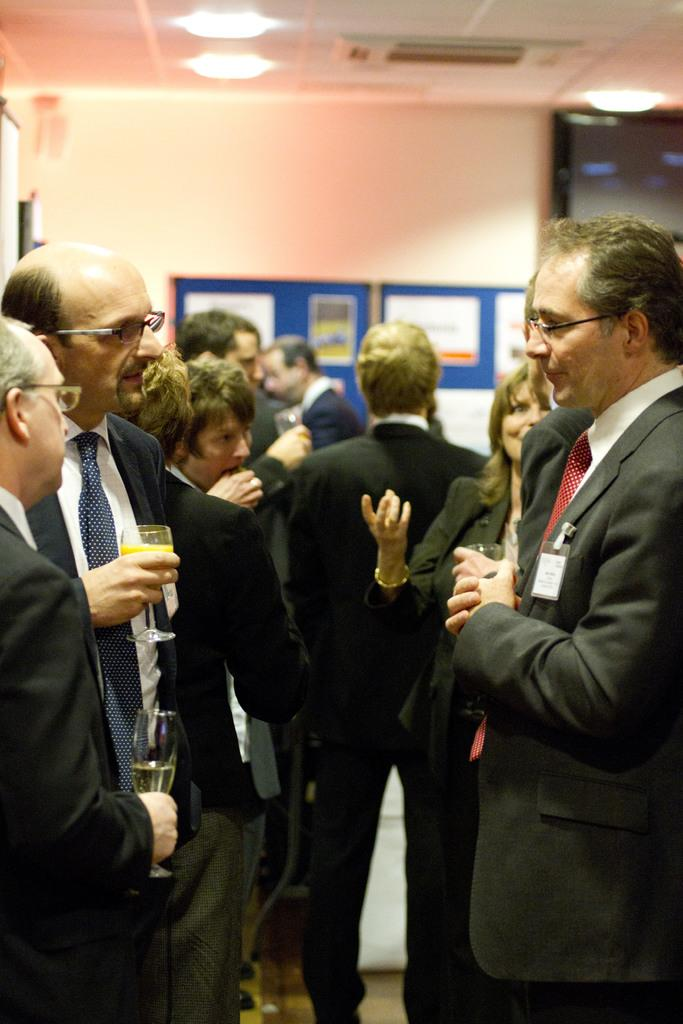What can be seen in the image involving people? There are people standing in the image. Where are the people standing? The people are standing on the floor. What is attached to the wall in the image? There is a board with posters on it in the image. How is the board with posters attached to the wall? The board is attached to the wall. What can be seen at the top of the image? There are lights visible at the top of the image. What type of list is the grandfather making for the girl in the image? There is no grandfather, girl, or list present in the image. 